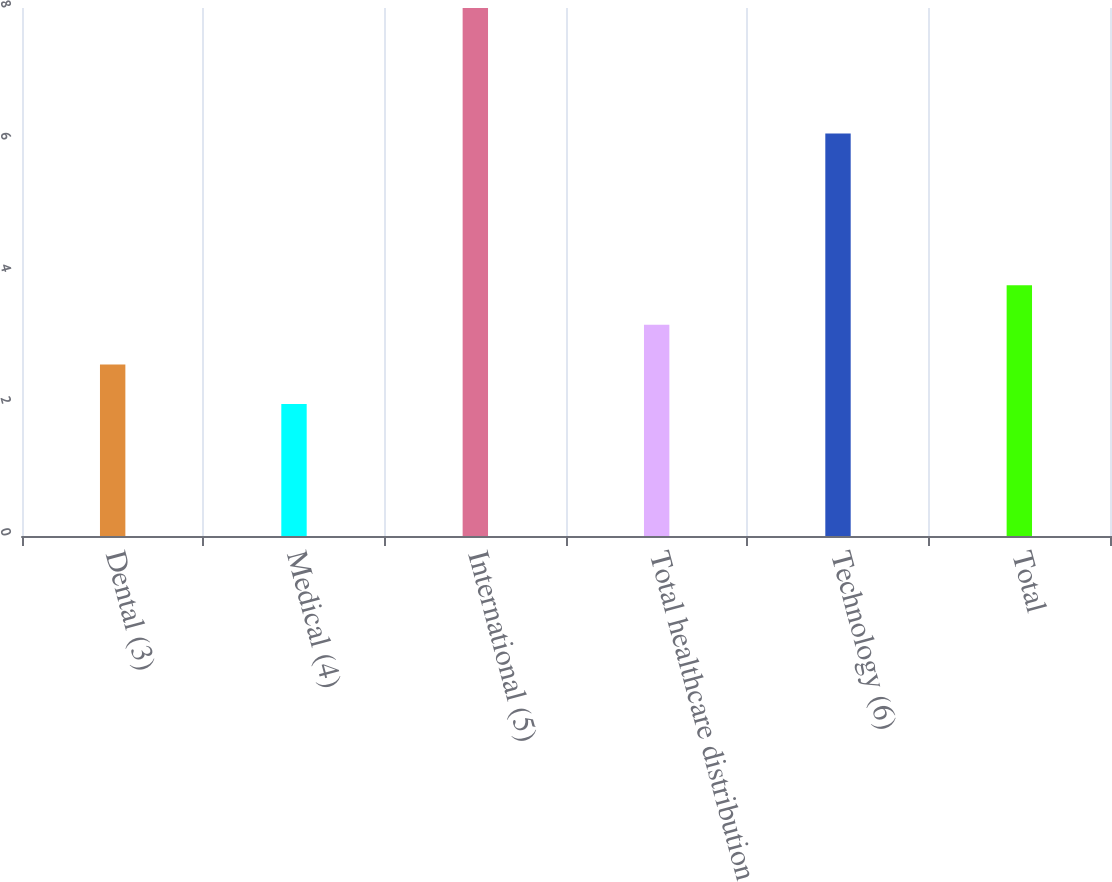<chart> <loc_0><loc_0><loc_500><loc_500><bar_chart><fcel>Dental (3)<fcel>Medical (4)<fcel>International (5)<fcel>Total healthcare distribution<fcel>Technology (6)<fcel>Total<nl><fcel>2.6<fcel>2<fcel>8<fcel>3.2<fcel>6.1<fcel>3.8<nl></chart> 